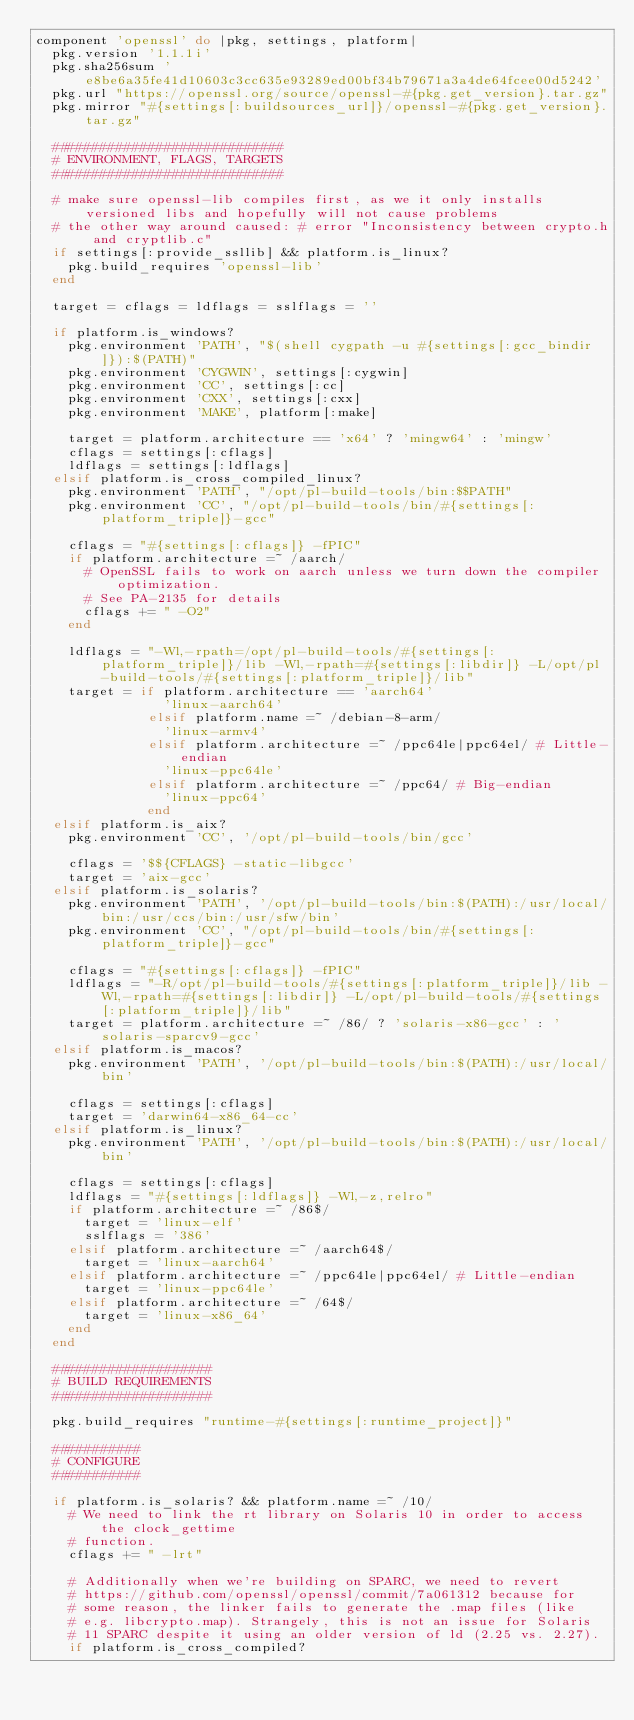Convert code to text. <code><loc_0><loc_0><loc_500><loc_500><_Ruby_>component 'openssl' do |pkg, settings, platform|
  pkg.version '1.1.1i'
  pkg.sha256sum 'e8be6a35fe41d10603c3cc635e93289ed00bf34b79671a3a4de64fcee00d5242'
  pkg.url "https://openssl.org/source/openssl-#{pkg.get_version}.tar.gz"
  pkg.mirror "#{settings[:buildsources_url]}/openssl-#{pkg.get_version}.tar.gz"

  #############################
  # ENVIRONMENT, FLAGS, TARGETS
  #############################

  # make sure openssl-lib compiles first, as we it only installs versioned libs and hopefully will not cause problems
  # the other way around caused: # error "Inconsistency between crypto.h and cryptlib.c"
  if settings[:provide_ssllib] && platform.is_linux?
    pkg.build_requires 'openssl-lib'
  end

  target = cflags = ldflags = sslflags = ''

  if platform.is_windows?
    pkg.environment 'PATH', "$(shell cygpath -u #{settings[:gcc_bindir]}):$(PATH)"
    pkg.environment 'CYGWIN', settings[:cygwin]
    pkg.environment 'CC', settings[:cc]
    pkg.environment 'CXX', settings[:cxx]
    pkg.environment 'MAKE', platform[:make]

    target = platform.architecture == 'x64' ? 'mingw64' : 'mingw'
    cflags = settings[:cflags]
    ldflags = settings[:ldflags]
  elsif platform.is_cross_compiled_linux?
    pkg.environment 'PATH', "/opt/pl-build-tools/bin:$$PATH"
    pkg.environment 'CC', "/opt/pl-build-tools/bin/#{settings[:platform_triple]}-gcc"

    cflags = "#{settings[:cflags]} -fPIC"
    if platform.architecture =~ /aarch/
      # OpenSSL fails to work on aarch unless we turn down the compiler optimization.
      # See PA-2135 for details
      cflags += " -O2"
    end

    ldflags = "-Wl,-rpath=/opt/pl-build-tools/#{settings[:platform_triple]}/lib -Wl,-rpath=#{settings[:libdir]} -L/opt/pl-build-tools/#{settings[:platform_triple]}/lib"
    target = if platform.architecture == 'aarch64'
                'linux-aarch64'
              elsif platform.name =~ /debian-8-arm/
                'linux-armv4'
              elsif platform.architecture =~ /ppc64le|ppc64el/ # Little-endian
                'linux-ppc64le'
              elsif platform.architecture =~ /ppc64/ # Big-endian
                'linux-ppc64'
              end
  elsif platform.is_aix?
    pkg.environment 'CC', '/opt/pl-build-tools/bin/gcc'

    cflags = '$${CFLAGS} -static-libgcc'
    target = 'aix-gcc'
  elsif platform.is_solaris?
    pkg.environment 'PATH', '/opt/pl-build-tools/bin:$(PATH):/usr/local/bin:/usr/ccs/bin:/usr/sfw/bin'
    pkg.environment 'CC', "/opt/pl-build-tools/bin/#{settings[:platform_triple]}-gcc"

    cflags = "#{settings[:cflags]} -fPIC"
    ldflags = "-R/opt/pl-build-tools/#{settings[:platform_triple]}/lib -Wl,-rpath=#{settings[:libdir]} -L/opt/pl-build-tools/#{settings[:platform_triple]}/lib"
    target = platform.architecture =~ /86/ ? 'solaris-x86-gcc' : 'solaris-sparcv9-gcc'
  elsif platform.is_macos?
    pkg.environment 'PATH', '/opt/pl-build-tools/bin:$(PATH):/usr/local/bin'

    cflags = settings[:cflags]
    target = 'darwin64-x86_64-cc'
  elsif platform.is_linux?
    pkg.environment 'PATH', '/opt/pl-build-tools/bin:$(PATH):/usr/local/bin'

    cflags = settings[:cflags]
    ldflags = "#{settings[:ldflags]} -Wl,-z,relro"
    if platform.architecture =~ /86$/
      target = 'linux-elf'
      sslflags = '386'
    elsif platform.architecture =~ /aarch64$/
      target = 'linux-aarch64'
    elsif platform.architecture =~ /ppc64le|ppc64el/ # Little-endian
      target = 'linux-ppc64le'
    elsif platform.architecture =~ /64$/
      target = 'linux-x86_64'
    end
  end

  ####################
  # BUILD REQUIREMENTS
  ####################

  pkg.build_requires "runtime-#{settings[:runtime_project]}"

  ###########
  # CONFIGURE
  ###########

  if platform.is_solaris? && platform.name =~ /10/
    # We need to link the rt library on Solaris 10 in order to access the clock_gettime
    # function.
    cflags += " -lrt"

    # Additionally when we're building on SPARC, we need to revert
    # https://github.com/openssl/openssl/commit/7a061312 because for
    # some reason, the linker fails to generate the .map files (like
    # e.g. libcrypto.map). Strangely, this is not an issue for Solaris
    # 11 SPARC despite it using an older version of ld (2.25 vs. 2.27).
    if platform.is_cross_compiled?</code> 